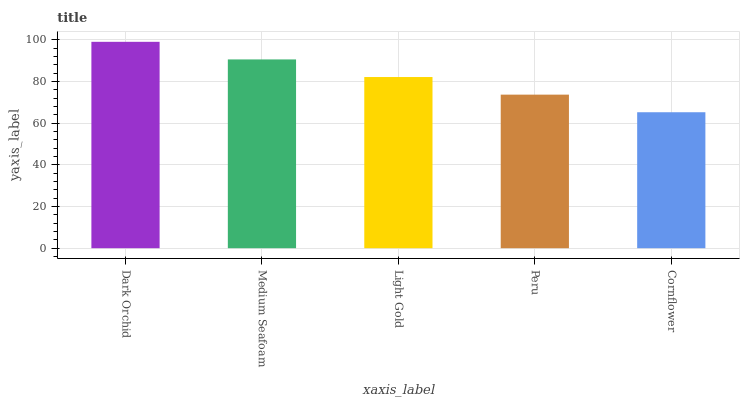Is Cornflower the minimum?
Answer yes or no. Yes. Is Dark Orchid the maximum?
Answer yes or no. Yes. Is Medium Seafoam the minimum?
Answer yes or no. No. Is Medium Seafoam the maximum?
Answer yes or no. No. Is Dark Orchid greater than Medium Seafoam?
Answer yes or no. Yes. Is Medium Seafoam less than Dark Orchid?
Answer yes or no. Yes. Is Medium Seafoam greater than Dark Orchid?
Answer yes or no. No. Is Dark Orchid less than Medium Seafoam?
Answer yes or no. No. Is Light Gold the high median?
Answer yes or no. Yes. Is Light Gold the low median?
Answer yes or no. Yes. Is Peru the high median?
Answer yes or no. No. Is Dark Orchid the low median?
Answer yes or no. No. 